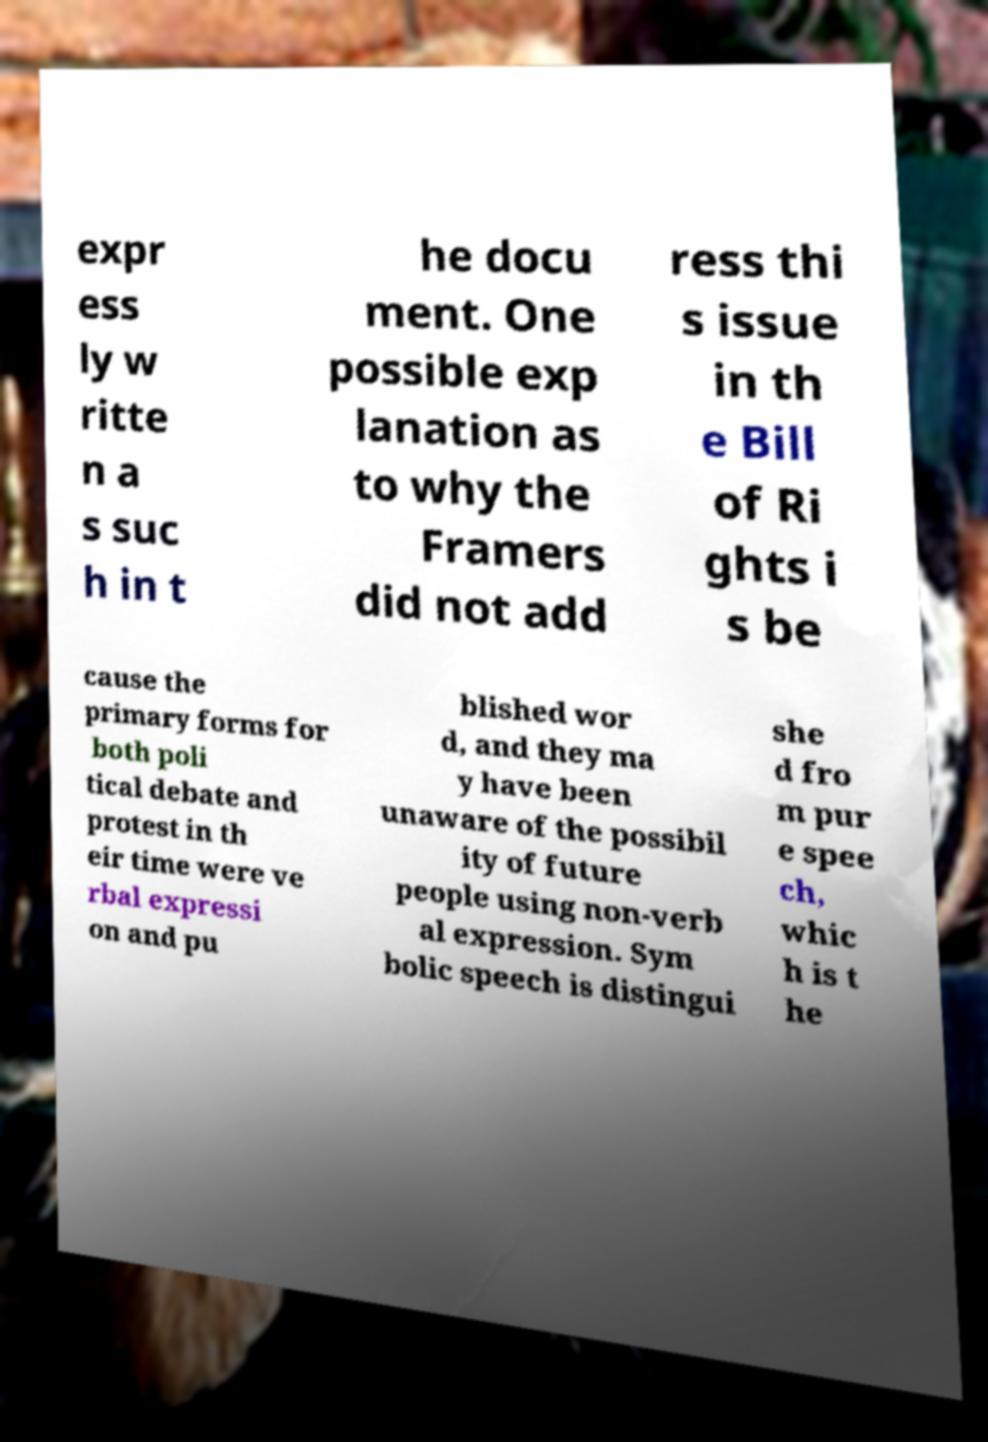For documentation purposes, I need the text within this image transcribed. Could you provide that? expr ess ly w ritte n a s suc h in t he docu ment. One possible exp lanation as to why the Framers did not add ress thi s issue in th e Bill of Ri ghts i s be cause the primary forms for both poli tical debate and protest in th eir time were ve rbal expressi on and pu blished wor d, and they ma y have been unaware of the possibil ity of future people using non-verb al expression. Sym bolic speech is distingui she d fro m pur e spee ch, whic h is t he 